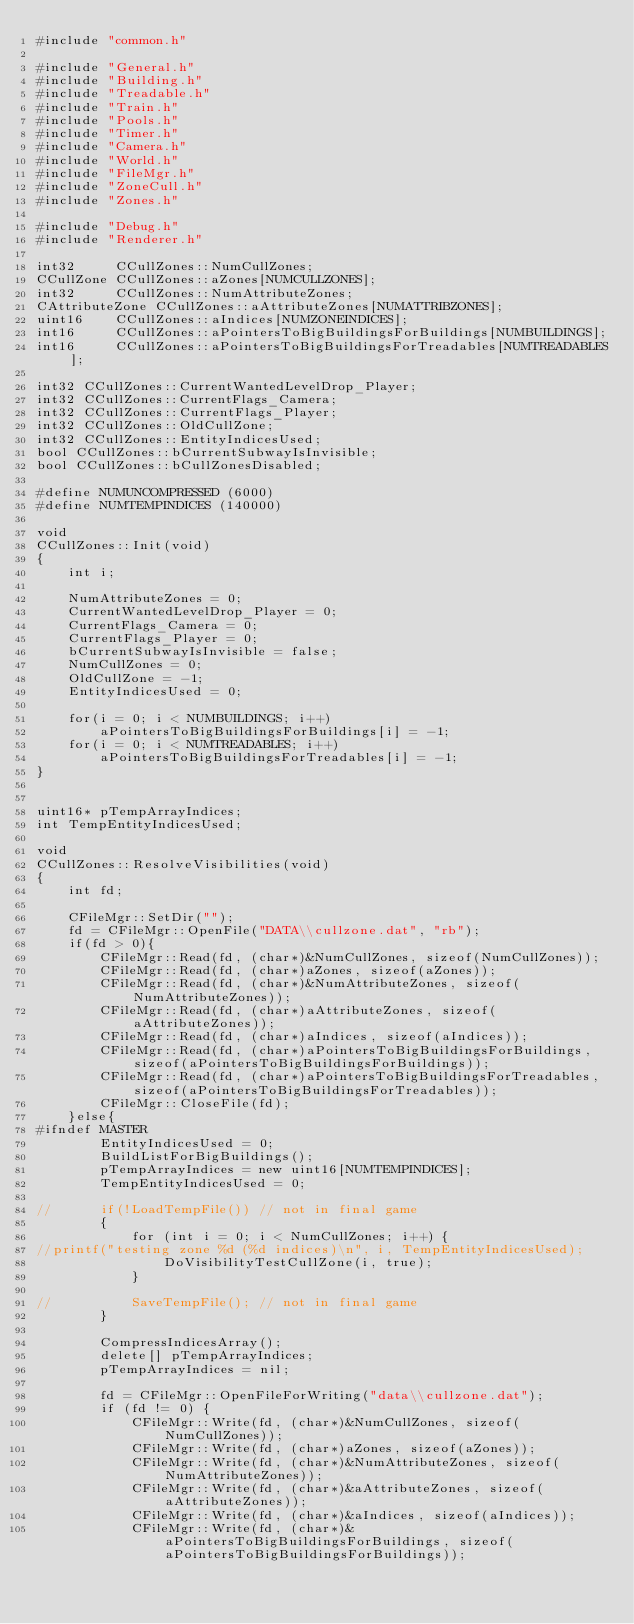Convert code to text. <code><loc_0><loc_0><loc_500><loc_500><_C++_>#include "common.h"

#include "General.h"
#include "Building.h"
#include "Treadable.h"
#include "Train.h"
#include "Pools.h"
#include "Timer.h"
#include "Camera.h"
#include "World.h"
#include "FileMgr.h"
#include "ZoneCull.h"
#include "Zones.h"

#include "Debug.h"
#include "Renderer.h"

int32     CCullZones::NumCullZones;
CCullZone CCullZones::aZones[NUMCULLZONES];
int32     CCullZones::NumAttributeZones;
CAttributeZone CCullZones::aAttributeZones[NUMATTRIBZONES];
uint16    CCullZones::aIndices[NUMZONEINDICES];
int16     CCullZones::aPointersToBigBuildingsForBuildings[NUMBUILDINGS];
int16     CCullZones::aPointersToBigBuildingsForTreadables[NUMTREADABLES];

int32 CCullZones::CurrentWantedLevelDrop_Player;
int32 CCullZones::CurrentFlags_Camera;
int32 CCullZones::CurrentFlags_Player;
int32 CCullZones::OldCullZone;
int32 CCullZones::EntityIndicesUsed;
bool CCullZones::bCurrentSubwayIsInvisible;
bool CCullZones::bCullZonesDisabled;

#define NUMUNCOMPRESSED (6000)
#define NUMTEMPINDICES (140000)

void
CCullZones::Init(void)
{
	int i;

	NumAttributeZones = 0;
	CurrentWantedLevelDrop_Player = 0;
	CurrentFlags_Camera = 0;
	CurrentFlags_Player = 0;
	bCurrentSubwayIsInvisible = false;
	NumCullZones = 0;
	OldCullZone = -1;
	EntityIndicesUsed = 0;

	for(i = 0; i < NUMBUILDINGS; i++)
		aPointersToBigBuildingsForBuildings[i] = -1;
	for(i = 0; i < NUMTREADABLES; i++)
		aPointersToBigBuildingsForTreadables[i] = -1;
}


uint16* pTempArrayIndices;
int TempEntityIndicesUsed;

void
CCullZones::ResolveVisibilities(void)
{
	int fd;

	CFileMgr::SetDir("");
	fd = CFileMgr::OpenFile("DATA\\cullzone.dat", "rb");
	if(fd > 0){
		CFileMgr::Read(fd, (char*)&NumCullZones, sizeof(NumCullZones));
		CFileMgr::Read(fd, (char*)aZones, sizeof(aZones));
		CFileMgr::Read(fd, (char*)&NumAttributeZones, sizeof(NumAttributeZones));
		CFileMgr::Read(fd, (char*)aAttributeZones, sizeof(aAttributeZones));
		CFileMgr::Read(fd, (char*)aIndices, sizeof(aIndices));
		CFileMgr::Read(fd, (char*)aPointersToBigBuildingsForBuildings, sizeof(aPointersToBigBuildingsForBuildings));
		CFileMgr::Read(fd, (char*)aPointersToBigBuildingsForTreadables, sizeof(aPointersToBigBuildingsForTreadables));
		CFileMgr::CloseFile(fd);
	}else{
#ifndef MASTER
		EntityIndicesUsed = 0;
		BuildListForBigBuildings();
		pTempArrayIndices = new uint16[NUMTEMPINDICES];
		TempEntityIndicesUsed = 0;

//		if(!LoadTempFile())	// not in final game
		{
			for (int i = 0; i < NumCullZones; i++) {
//printf("testing zone %d (%d indices)\n", i, TempEntityIndicesUsed);
				DoVisibilityTestCullZone(i, true);
			}

//			SaveTempFile();	// not in final game
		}

		CompressIndicesArray();
		delete[] pTempArrayIndices;
		pTempArrayIndices = nil;

		fd = CFileMgr::OpenFileForWriting("data\\cullzone.dat");
		if (fd != 0) {
			CFileMgr::Write(fd, (char*)&NumCullZones, sizeof(NumCullZones));
			CFileMgr::Write(fd, (char*)aZones, sizeof(aZones));
			CFileMgr::Write(fd, (char*)&NumAttributeZones, sizeof(NumAttributeZones));
			CFileMgr::Write(fd, (char*)&aAttributeZones, sizeof(aAttributeZones));
			CFileMgr::Write(fd, (char*)&aIndices, sizeof(aIndices));
			CFileMgr::Write(fd, (char*)&aPointersToBigBuildingsForBuildings, sizeof(aPointersToBigBuildingsForBuildings));</code> 